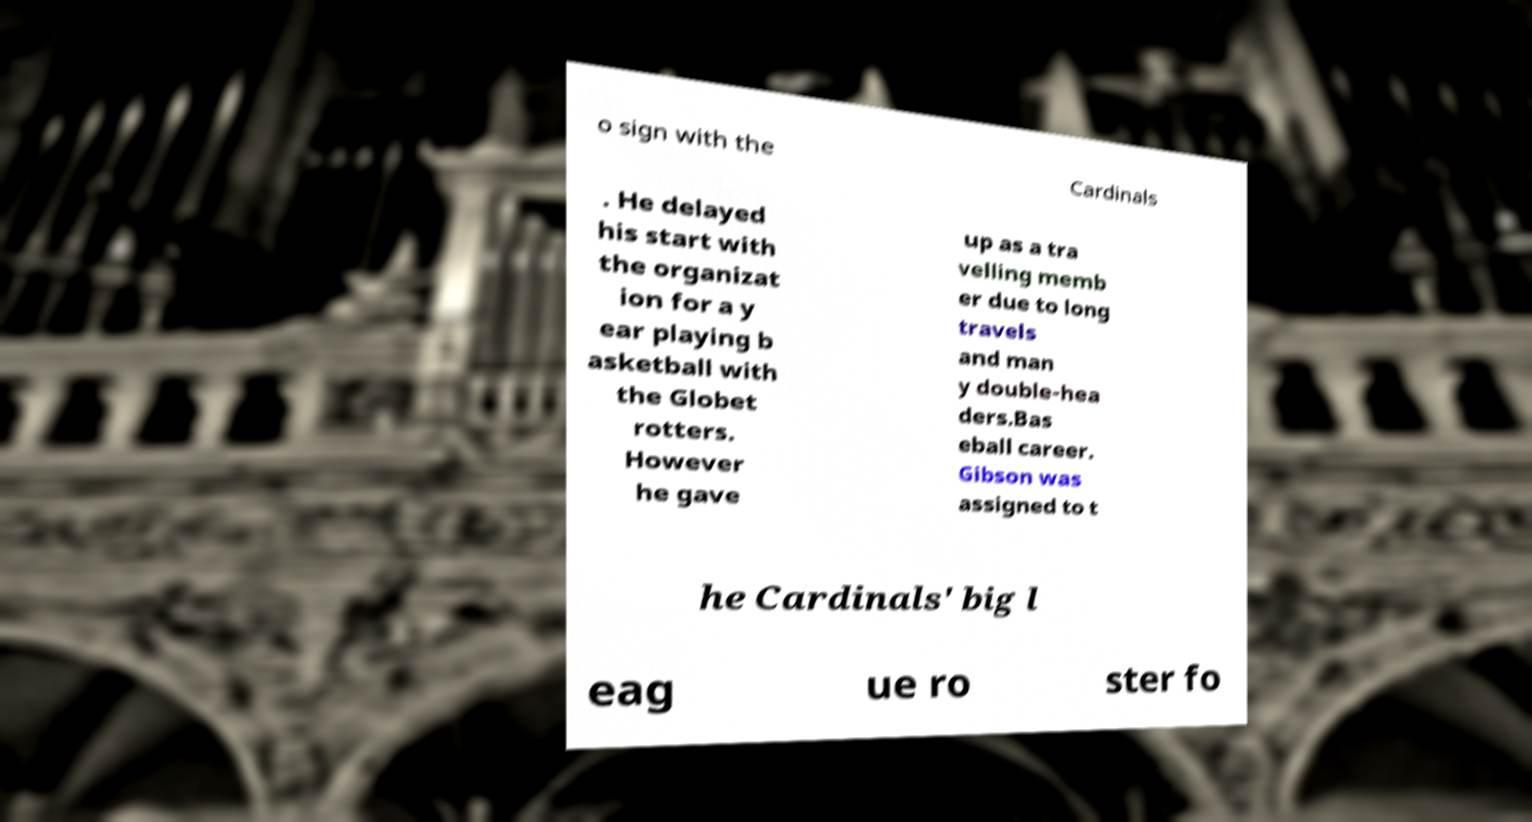Could you assist in decoding the text presented in this image and type it out clearly? o sign with the Cardinals . He delayed his start with the organizat ion for a y ear playing b asketball with the Globet rotters. However he gave up as a tra velling memb er due to long travels and man y double-hea ders.Bas eball career. Gibson was assigned to t he Cardinals' big l eag ue ro ster fo 